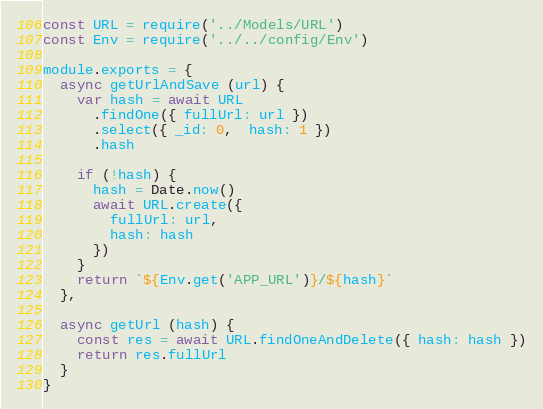Convert code to text. <code><loc_0><loc_0><loc_500><loc_500><_JavaScript_>const URL = require('../Models/URL')
const Env = require('../../config/Env')

module.exports = {
  async getUrlAndSave (url) {
    var hash = await URL
      .findOne({ fullUrl: url })
      .select({ _id: 0,  hash: 1 })
      .hash

    if (!hash) {
      hash = Date.now()
      await URL.create({
        fullUrl: url,
        hash: hash
      })
    }
    return `${Env.get('APP_URL')}/${hash}`
  },

  async getUrl (hash) {
    const res = await URL.findOneAndDelete({ hash: hash })
    return res.fullUrl
  }
}</code> 